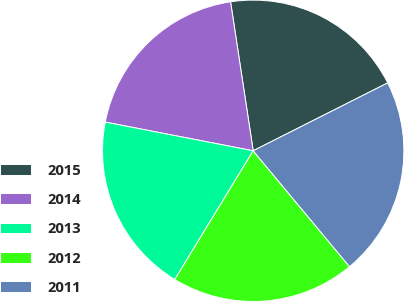Convert chart. <chart><loc_0><loc_0><loc_500><loc_500><pie_chart><fcel>2015<fcel>2014<fcel>2013<fcel>2012<fcel>2011<nl><fcel>19.96%<fcel>19.55%<fcel>19.34%<fcel>19.75%<fcel>21.4%<nl></chart> 